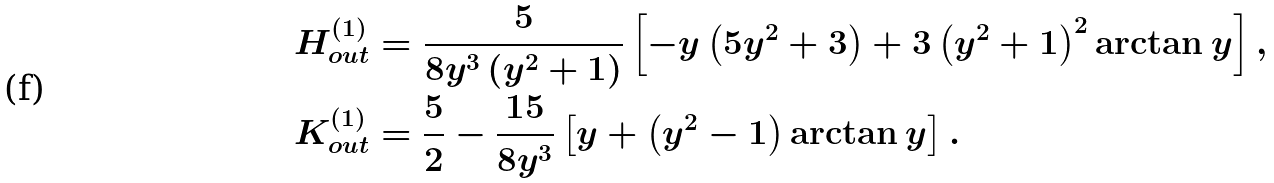<formula> <loc_0><loc_0><loc_500><loc_500>& H ^ { ( 1 ) } _ { o u t } = \frac { 5 } { 8 y ^ { 3 } \left ( y ^ { 2 } + 1 \right ) } \left [ - y \left ( 5 y ^ { 2 } + 3 \right ) + 3 \left ( y ^ { 2 } + 1 \right ) ^ { 2 } \arctan y \right ] , \\ & K ^ { ( 1 ) } _ { o u t } = \frac { 5 } { 2 } - \frac { 1 5 } { 8 y ^ { 3 } } \left [ y + \left ( y ^ { 2 } - 1 \right ) \arctan y \right ] .</formula> 